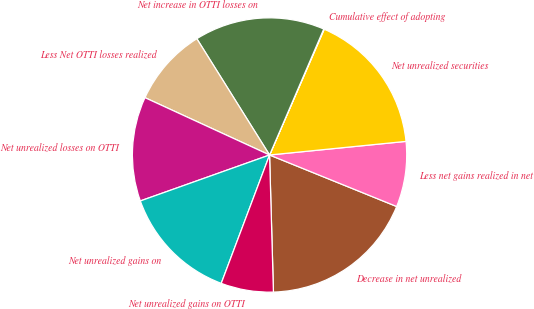<chart> <loc_0><loc_0><loc_500><loc_500><pie_chart><fcel>Decrease in net unrealized<fcel>Less net gains realized in net<fcel>Net unrealized securities<fcel>Cumulative effect of adopting<fcel>Net increase in OTTI losses on<fcel>Less Net OTTI losses realized<fcel>Net unrealized losses on OTTI<fcel>Net unrealized gains on<fcel>Net unrealized gains on OTTI<nl><fcel>18.42%<fcel>7.71%<fcel>16.89%<fcel>0.06%<fcel>15.36%<fcel>9.24%<fcel>12.3%<fcel>13.83%<fcel>6.18%<nl></chart> 